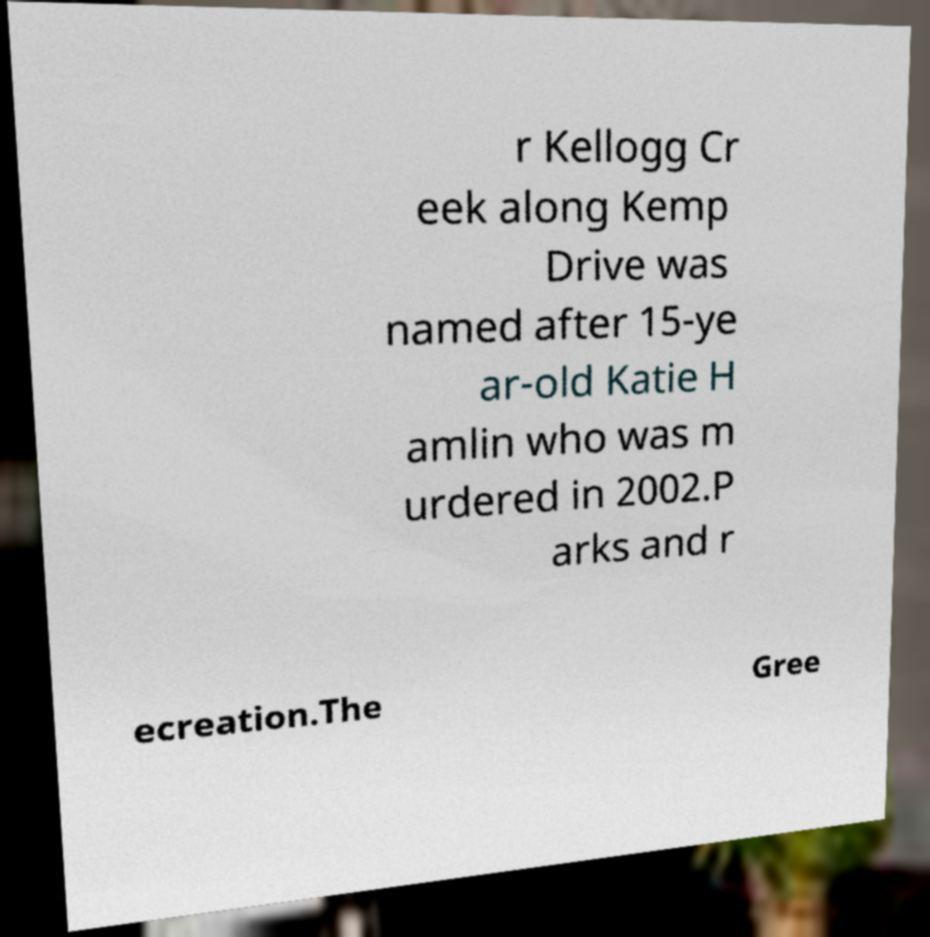Could you extract and type out the text from this image? r Kellogg Cr eek along Kemp Drive was named after 15-ye ar-old Katie H amlin who was m urdered in 2002.P arks and r ecreation.The Gree 